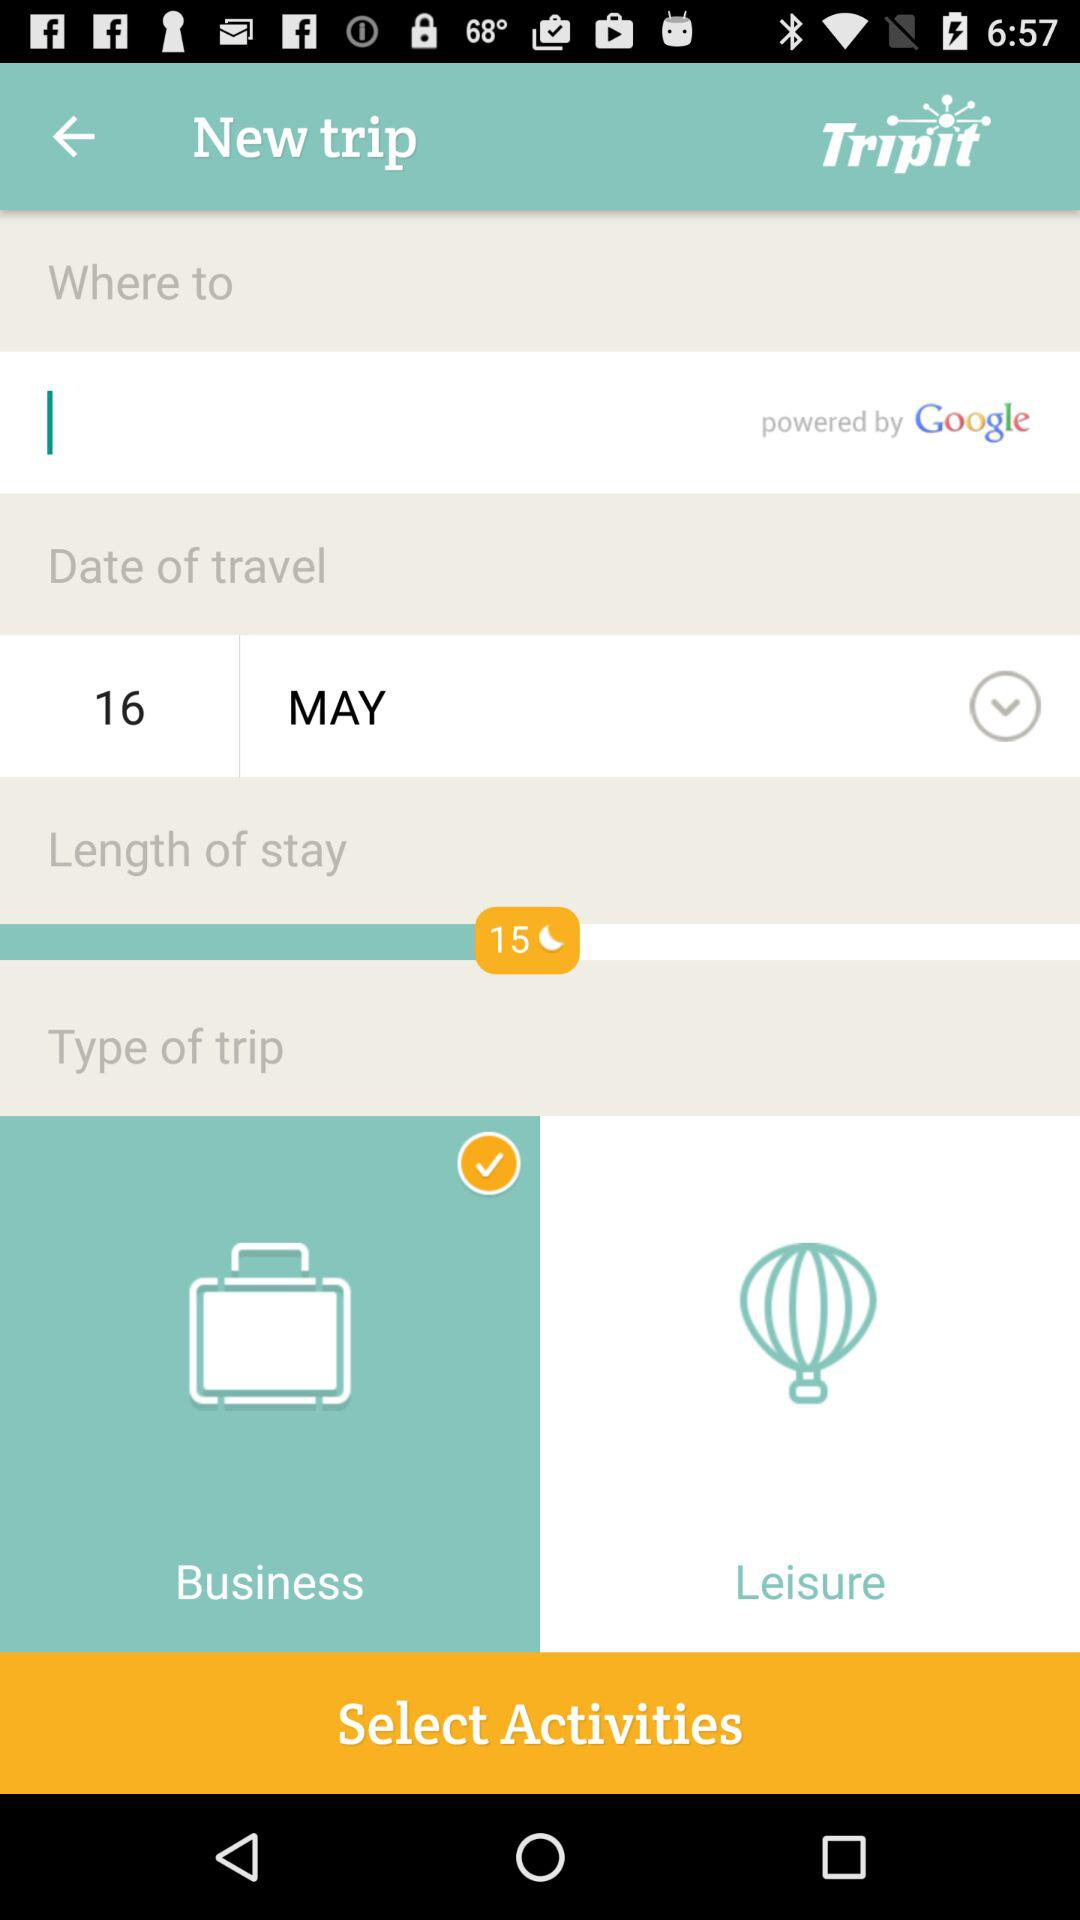What is the type of trip? The type of trip is "Business". 